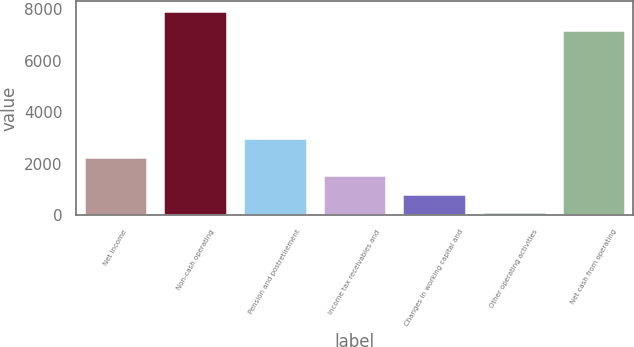<chart> <loc_0><loc_0><loc_500><loc_500><bar_chart><fcel>Net income<fcel>Non-cash operating<fcel>Pension and postretirement<fcel>Income tax receivables and<fcel>Changes in working capital and<fcel>Other operating activities<fcel>Net cash from operating<nl><fcel>2277.2<fcel>7935.4<fcel>2996.6<fcel>1557.8<fcel>838.4<fcel>119<fcel>7216<nl></chart> 